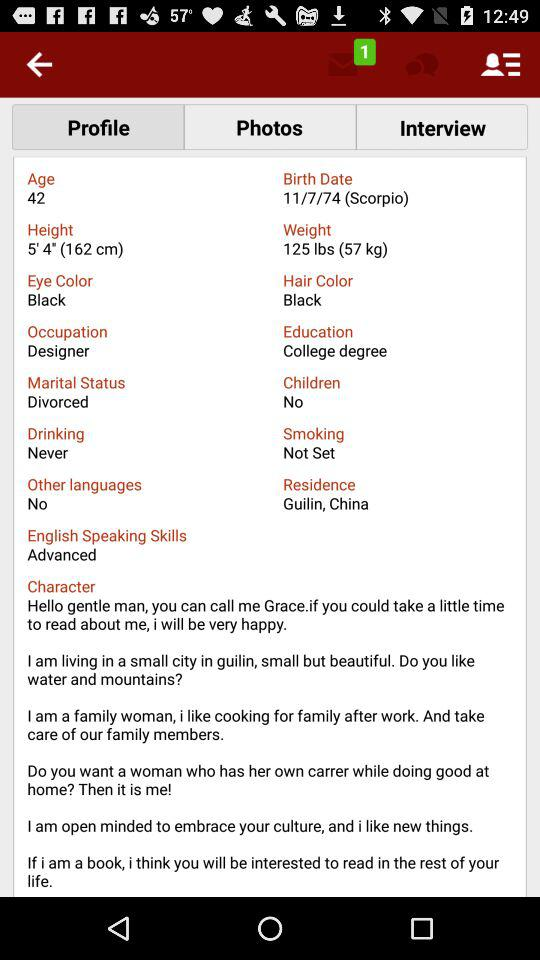What is the total number of languages Grace speaks?
Answer the question using a single word or phrase. 1 